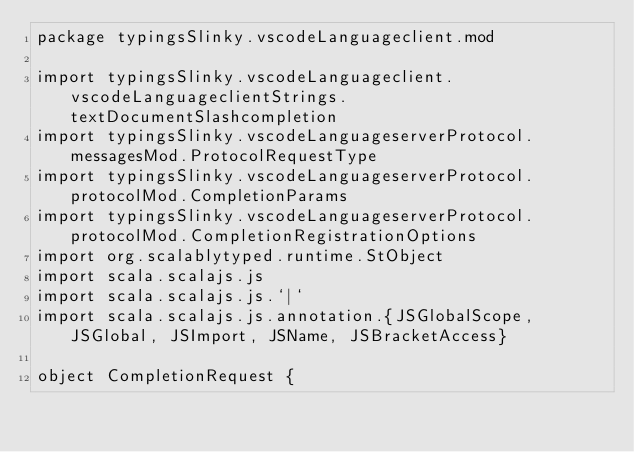Convert code to text. <code><loc_0><loc_0><loc_500><loc_500><_Scala_>package typingsSlinky.vscodeLanguageclient.mod

import typingsSlinky.vscodeLanguageclient.vscodeLanguageclientStrings.textDocumentSlashcompletion
import typingsSlinky.vscodeLanguageserverProtocol.messagesMod.ProtocolRequestType
import typingsSlinky.vscodeLanguageserverProtocol.protocolMod.CompletionParams
import typingsSlinky.vscodeLanguageserverProtocol.protocolMod.CompletionRegistrationOptions
import org.scalablytyped.runtime.StObject
import scala.scalajs.js
import scala.scalajs.js.`|`
import scala.scalajs.js.annotation.{JSGlobalScope, JSGlobal, JSImport, JSName, JSBracketAccess}

object CompletionRequest {
  </code> 